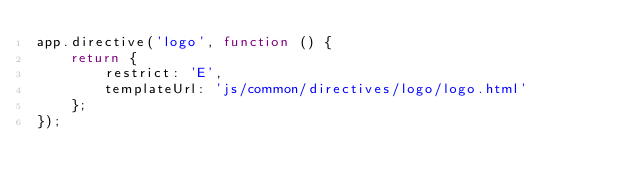Convert code to text. <code><loc_0><loc_0><loc_500><loc_500><_JavaScript_>app.directive('logo', function () {
    return {
        restrict: 'E',
        templateUrl: 'js/common/directives/logo/logo.html'
    };
});</code> 